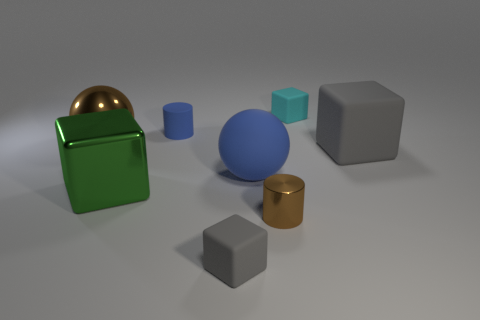Add 2 small red matte objects. How many objects exist? 10 Subtract all cylinders. How many objects are left? 6 Add 2 brown metal cylinders. How many brown metal cylinders exist? 3 Subtract 0 yellow spheres. How many objects are left? 8 Subtract all tiny things. Subtract all big blue rubber spheres. How many objects are left? 3 Add 7 gray blocks. How many gray blocks are left? 9 